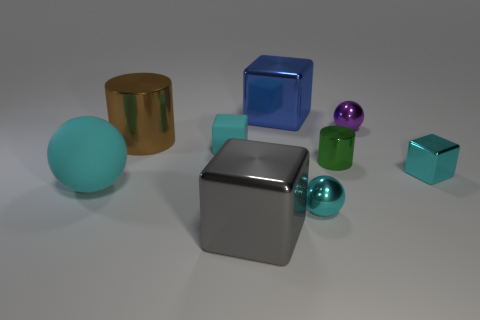Subtract all cubes. How many objects are left? 5 Subtract all large metallic things. Subtract all tiny shiny blocks. How many objects are left? 5 Add 2 cyan matte spheres. How many cyan matte spheres are left? 3 Add 3 large cyan balls. How many large cyan balls exist? 4 Subtract 0 yellow spheres. How many objects are left? 9 